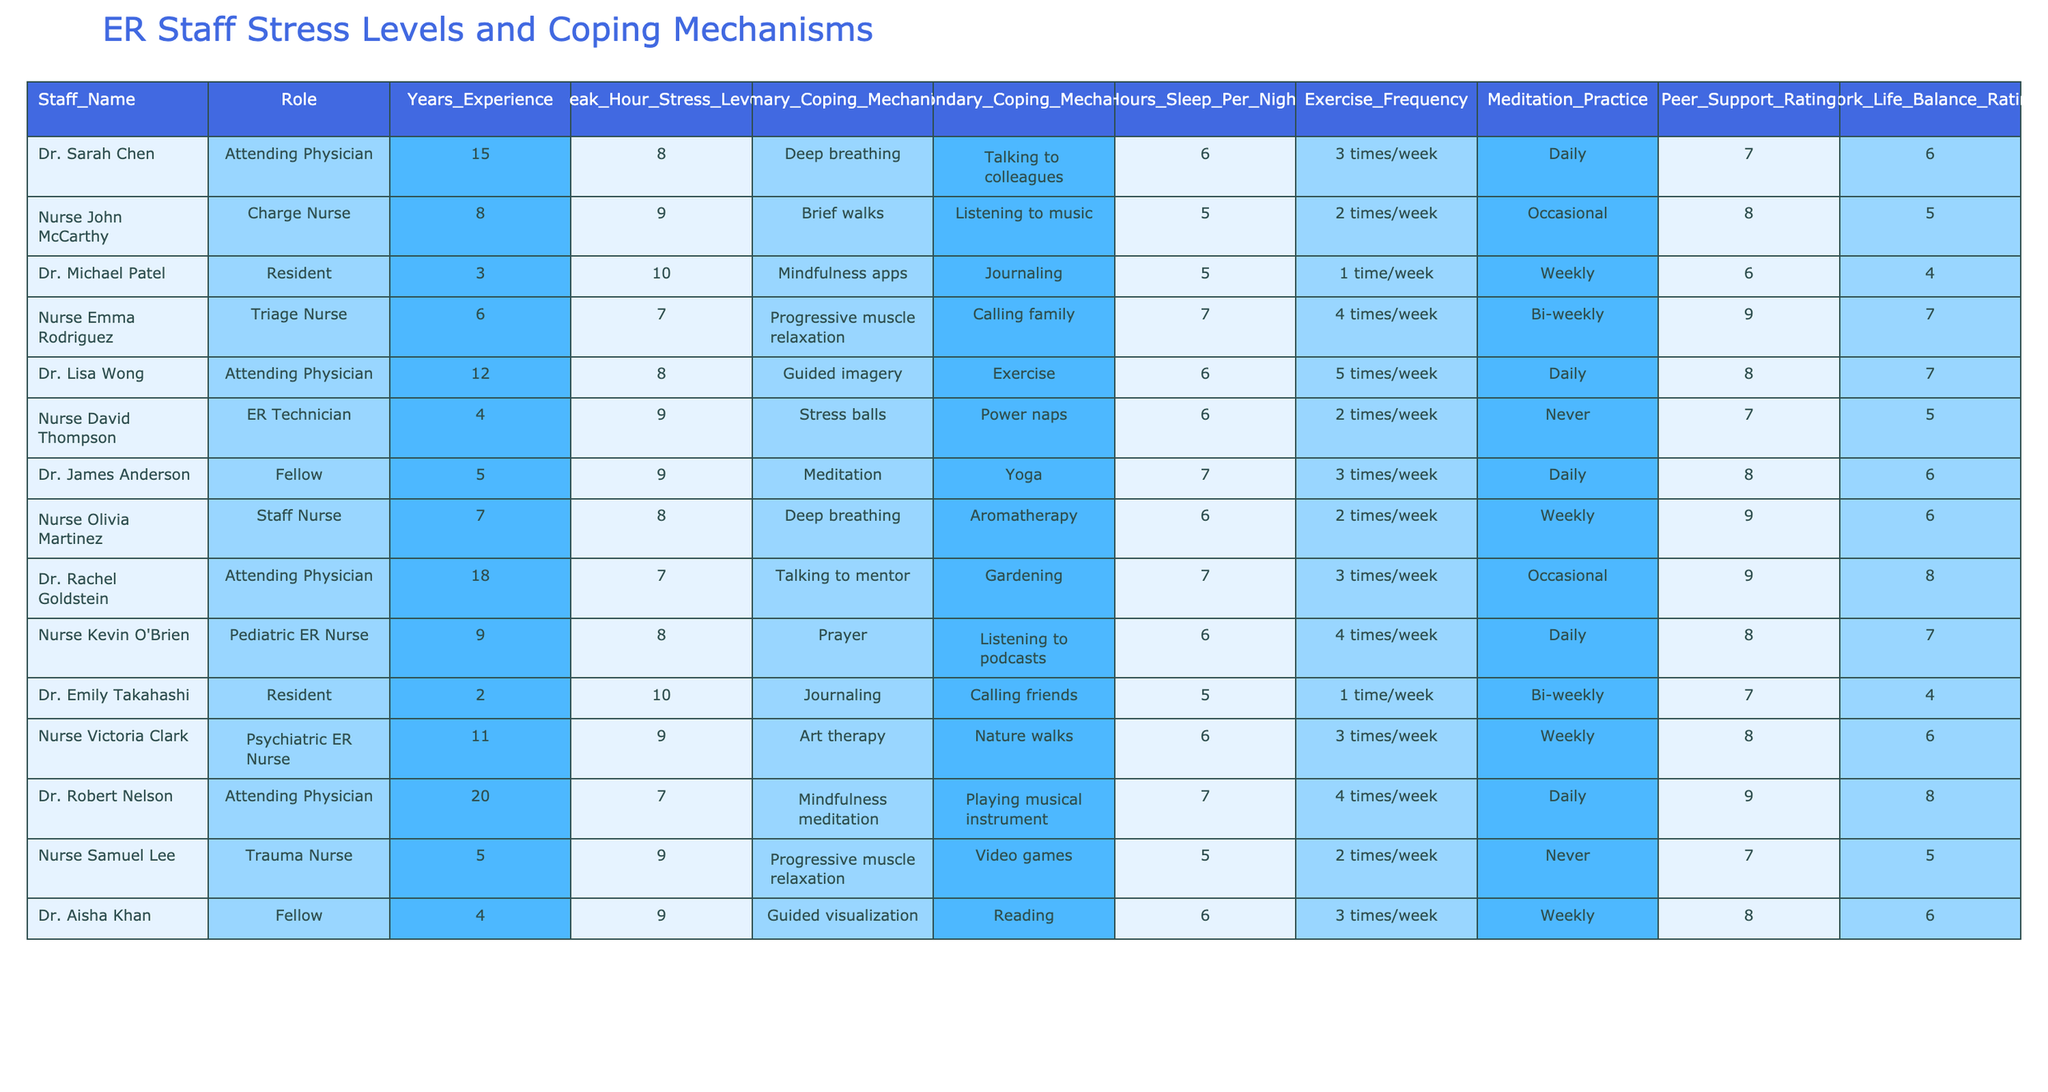What is the Peak Hour Stress Level for Dr. Sarah Chen? Dr. Sarah Chen's Peak Hour Stress Level is explicitly listed in the table. Just locate the corresponding row for Dr. Sarah Chen and check the relevant column.
Answer: 8 Which staff member has the highest Peak Hour Stress Level? To determine this, review the "Peak Hour Stress Level" column across all staff members and identify the maximum value. In this case, Dr. Michael Patel has the highest level at 10.
Answer: Dr. Michael Patel What is the average Hours of Sleep per Night for the ER staff listed? First, sum the Hours of Sleep for all employees: 6 + 5 + 5 + 7 + 6 + 6 + 7 + 6 + 7 + 6 + 7 + 6 + 6 = 79. Then, divide by the number of staff members, which is 13: 79/13 = 6.08.
Answer: 6.08 Is it true that all attending physicians have a Peak Hour Stress Level of 8 or lower? Review the Peak Hour Stress Levels of all attending physicians listed in the table. Dr. Michael Patel has a level of 10, which contradicts the claim.
Answer: No What is the role of the staff member who practices mindfulness meditation as their Primary Coping Mechanism? Look for the entry where the Primary Coping Mechanism is mindfulness meditation and note the associated Role in that row. In the table, Dr. Robert Nelson fulfills this criterion as an attending physician.
Answer: Attending Physician Which coping mechanism is most commonly recorded as a Primary Coping Mechanism among all staff? Count the occurrences of each Primary Coping Mechanism in the table. Based on the entries given, Deep breathing appears twice, indicating it is the most common.
Answer: Deep breathing How many staff members reported a Peer Support Rating of 8 or higher? Filter through the Peer Support Rating column and count how many members have ratings of 8 or more. The involved staff include Nurse John McCarthy, Nurse Emma Rodriguez, Dr. James Anderson, Dr. Rachel Goldstein, Dr. Robert Nelson, and Nurse Kevin O’Brien, totaling 6 staff members.
Answer: 6 What is the difference between the highest and lowest Peak Hour Stress Levels? Identify the highest Peak Hour Stress Level (10 from Dr. Michael Patel) and the lowest Peak Hour Stress Level (7 from Dr. Rachel Goldstein and Dr. Robert Nelson). The difference is 10 - 7 = 3.
Answer: 3 Which exercise frequency is associated with Nurse David Thompson? Locate Nurse David Thompson’s row in the table and check the Exercise Frequency column to find the associated value, which is 2 times/week.
Answer: 2 times/week Which staff member has a higher Work-Life Balance Rating: Dr. Lisa Wong or Nurse Olivia Martinez? Compare the Work-Life Balance Ratings of both staff members directly from the table: Dr. Lisa Wong has a rating of 7, while Nurse Olivia Martinez's rating is also 6. Therefore, Dr. Lisa Wong has a higher rating.
Answer: Dr. Lisa Wong 